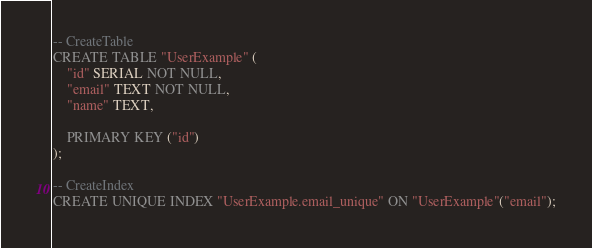Convert code to text. <code><loc_0><loc_0><loc_500><loc_500><_SQL_>-- CreateTable
CREATE TABLE "UserExample" (
    "id" SERIAL NOT NULL,
    "email" TEXT NOT NULL,
    "name" TEXT,

    PRIMARY KEY ("id")
);

-- CreateIndex
CREATE UNIQUE INDEX "UserExample.email_unique" ON "UserExample"("email");
</code> 